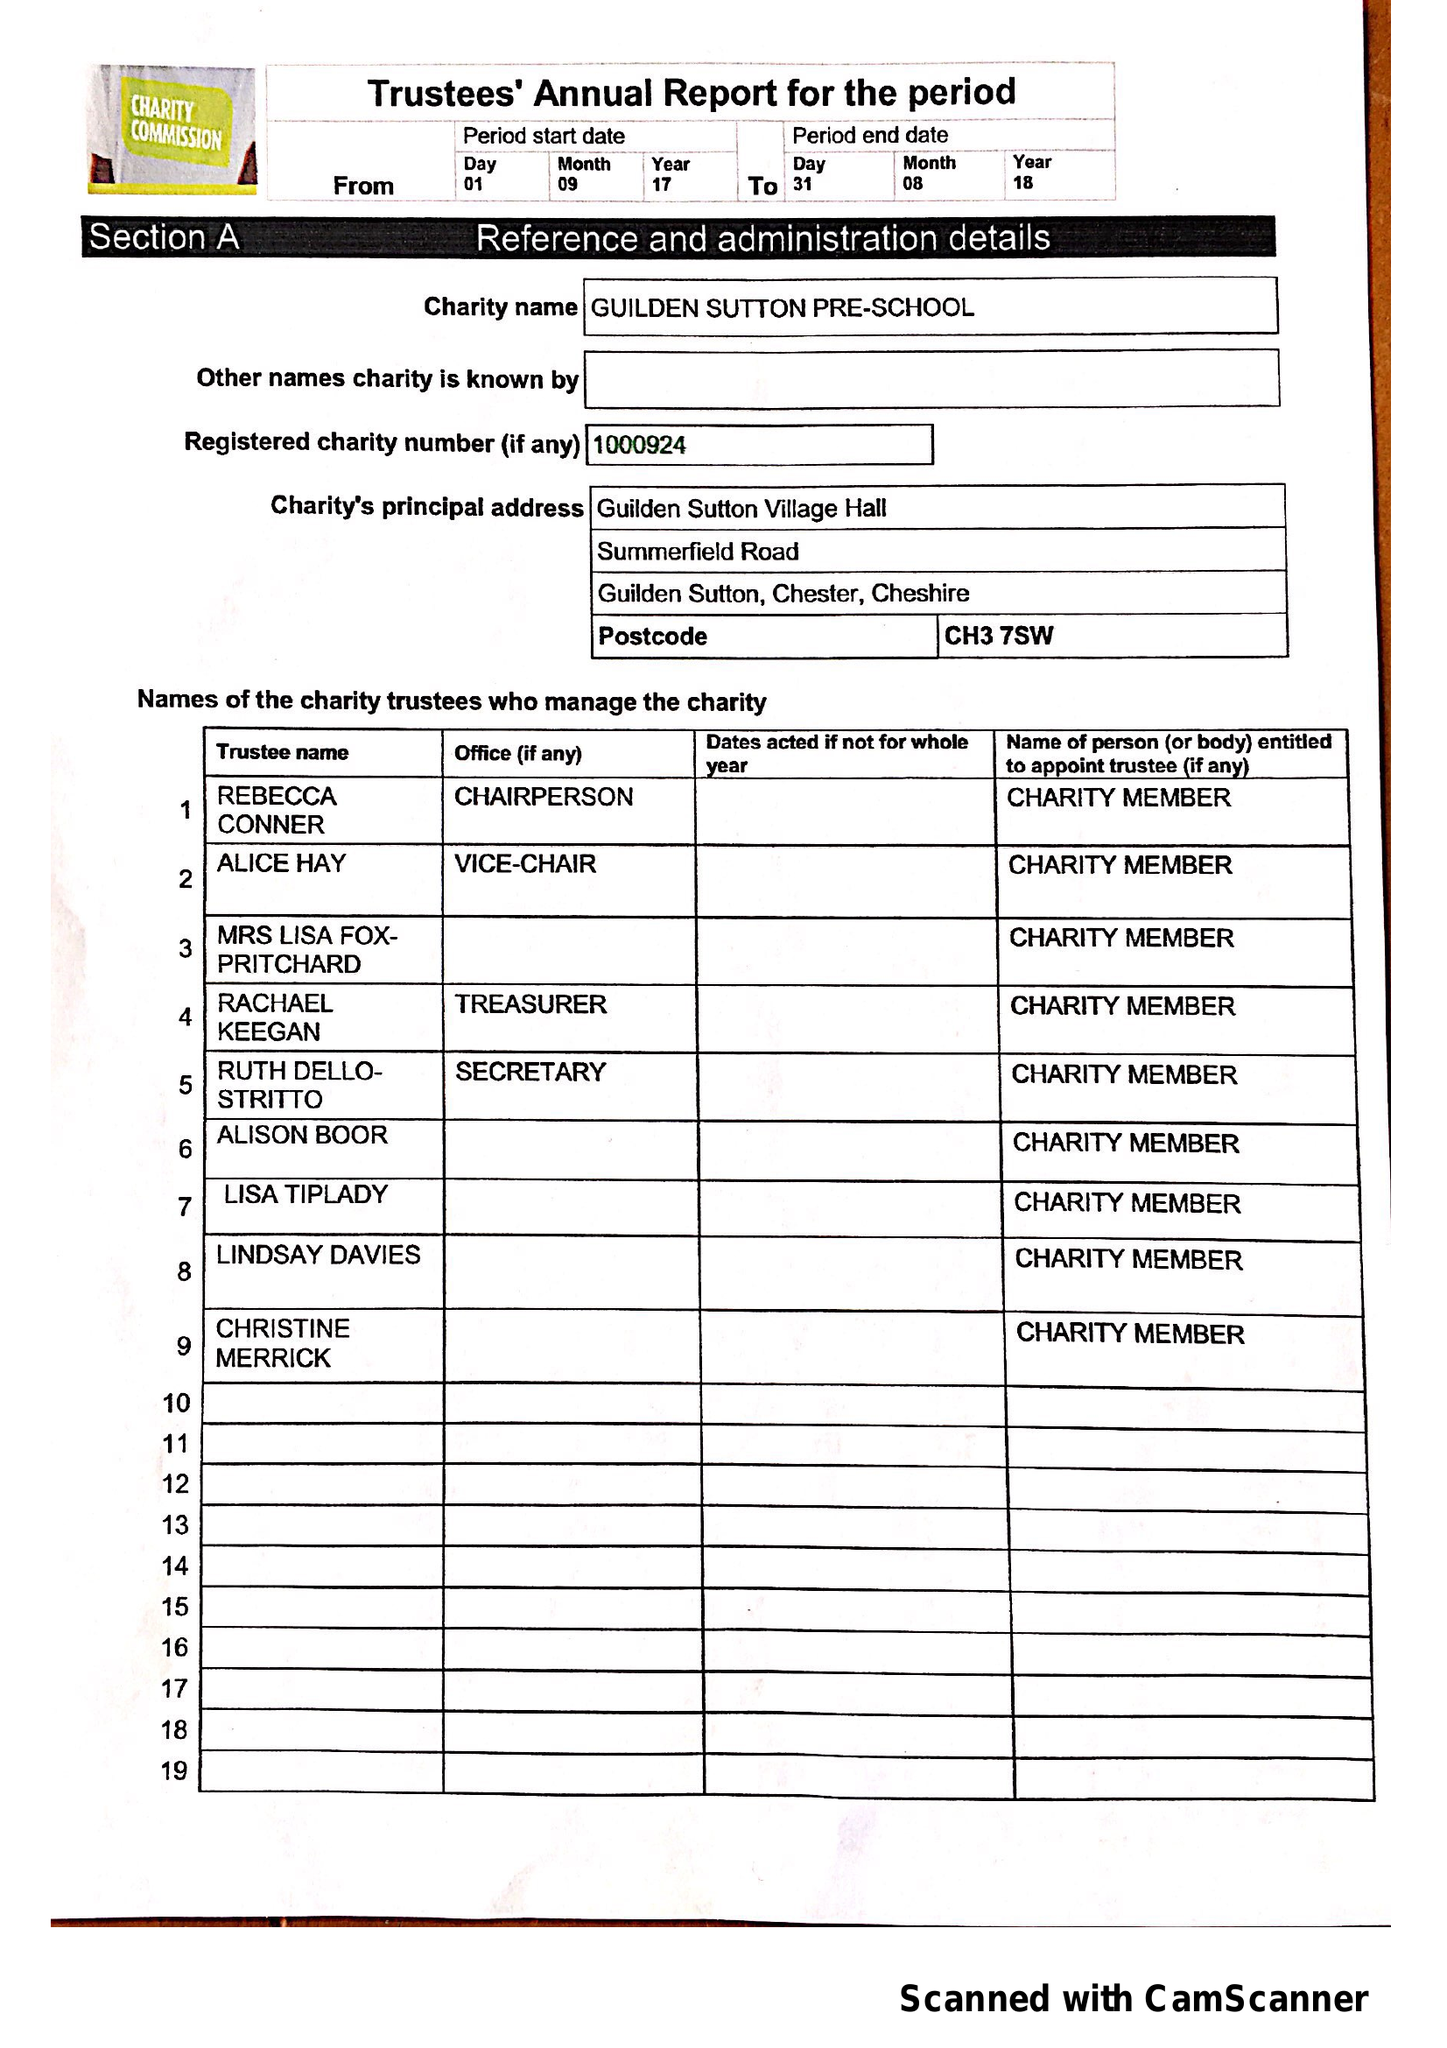What is the value for the charity_name?
Answer the question using a single word or phrase. Guilden Sutton Pre-School 